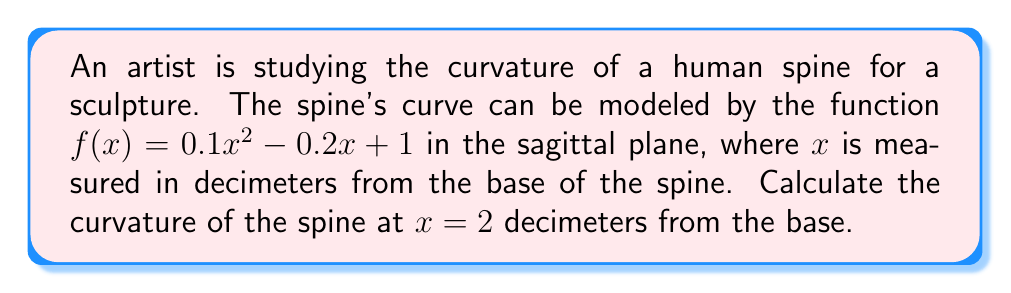Teach me how to tackle this problem. To find the curvature of the spine, we'll use the curvature formula for a function $y = f(x)$:

$$\kappa = \frac{|f''(x)|}{(1 + [f'(x)]^2)^{3/2}}$$

Step 1: Find $f'(x)$ and $f''(x)$
$f(x) = 0.1x^2 - 0.2x + 1$
$f'(x) = 0.2x - 0.2$
$f''(x) = 0.2$

Step 2: Evaluate $f'(x)$ at $x = 2$
$f'(2) = 0.2(2) - 0.2 = 0.2$

Step 3: Substitute values into the curvature formula
$$\kappa = \frac{|0.2|}{(1 + [0.2]^2)^{3/2}}$$

Step 4: Simplify
$$\kappa = \frac{0.2}{(1 + 0.04)^{3/2}} = \frac{0.2}{(1.04)^{3/2}}$$

Step 5: Calculate the final result
$$\kappa \approx 0.1942 \text{ dm}^{-1}$$
Answer: $0.1942 \text{ dm}^{-1}$ 